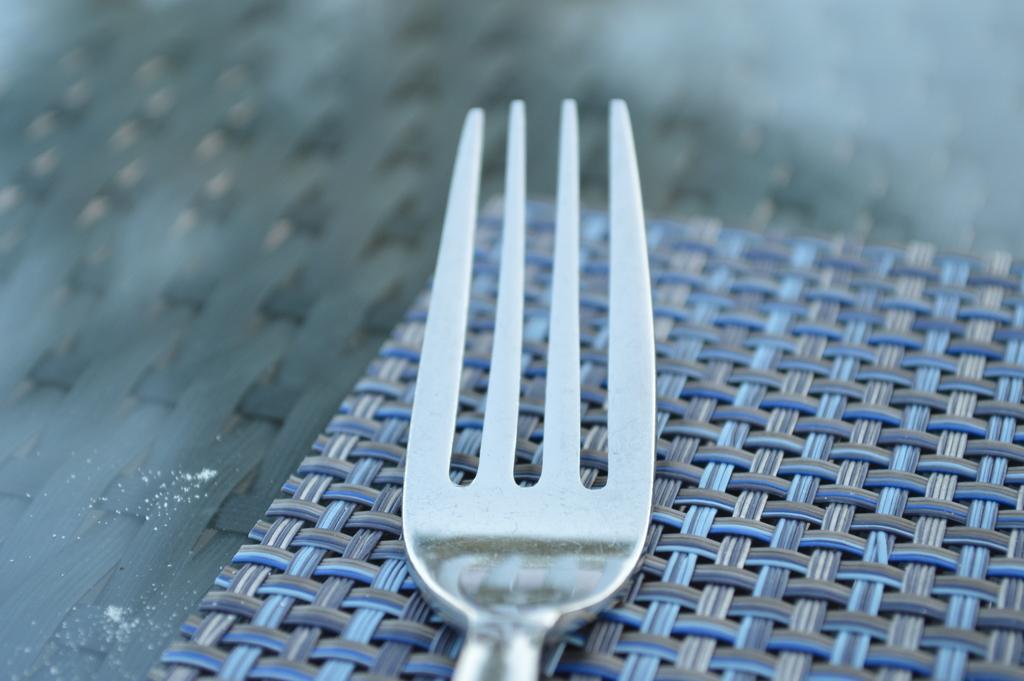Describe this image in one or two sentences. In the picture we can see a fork, which is placed on the mat which is blue in color. 